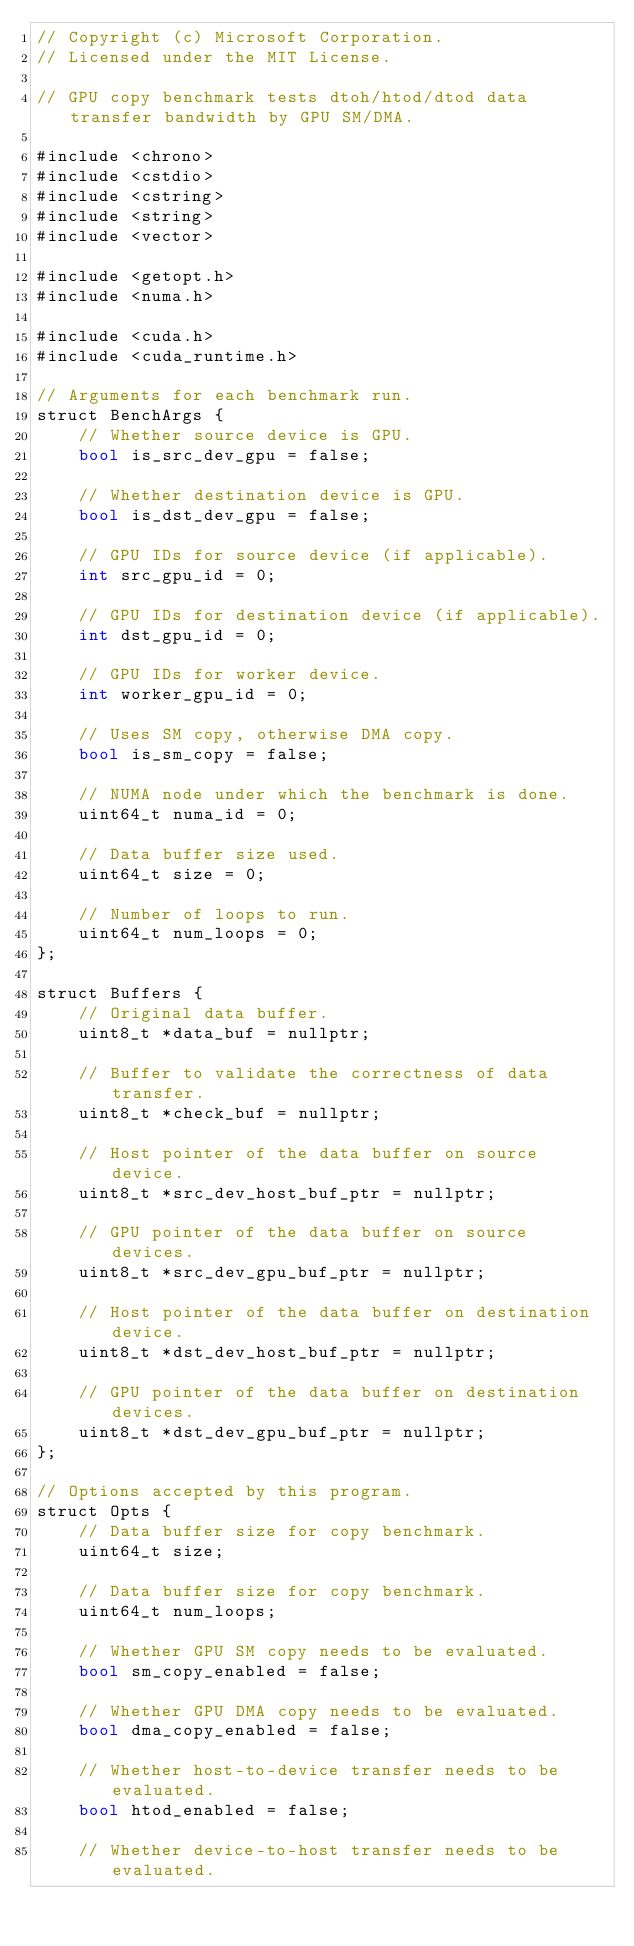Convert code to text. <code><loc_0><loc_0><loc_500><loc_500><_Cuda_>// Copyright (c) Microsoft Corporation.
// Licensed under the MIT License.

// GPU copy benchmark tests dtoh/htod/dtod data transfer bandwidth by GPU SM/DMA.

#include <chrono>
#include <cstdio>
#include <cstring>
#include <string>
#include <vector>

#include <getopt.h>
#include <numa.h>

#include <cuda.h>
#include <cuda_runtime.h>

// Arguments for each benchmark run.
struct BenchArgs {
    // Whether source device is GPU.
    bool is_src_dev_gpu = false;

    // Whether destination device is GPU.
    bool is_dst_dev_gpu = false;

    // GPU IDs for source device (if applicable).
    int src_gpu_id = 0;

    // GPU IDs for destination device (if applicable).
    int dst_gpu_id = 0;

    // GPU IDs for worker device.
    int worker_gpu_id = 0;

    // Uses SM copy, otherwise DMA copy.
    bool is_sm_copy = false;

    // NUMA node under which the benchmark is done.
    uint64_t numa_id = 0;

    // Data buffer size used.
    uint64_t size = 0;

    // Number of loops to run.
    uint64_t num_loops = 0;
};

struct Buffers {
    // Original data buffer.
    uint8_t *data_buf = nullptr;

    // Buffer to validate the correctness of data transfer.
    uint8_t *check_buf = nullptr;

    // Host pointer of the data buffer on source device.
    uint8_t *src_dev_host_buf_ptr = nullptr;

    // GPU pointer of the data buffer on source devices.
    uint8_t *src_dev_gpu_buf_ptr = nullptr;

    // Host pointer of the data buffer on destination device.
    uint8_t *dst_dev_host_buf_ptr = nullptr;

    // GPU pointer of the data buffer on destination devices.
    uint8_t *dst_dev_gpu_buf_ptr = nullptr;
};

// Options accepted by this program.
struct Opts {
    // Data buffer size for copy benchmark.
    uint64_t size;

    // Data buffer size for copy benchmark.
    uint64_t num_loops;

    // Whether GPU SM copy needs to be evaluated.
    bool sm_copy_enabled = false;

    // Whether GPU DMA copy needs to be evaluated.
    bool dma_copy_enabled = false;

    // Whether host-to-device transfer needs to be evaluated.
    bool htod_enabled = false;

    // Whether device-to-host transfer needs to be evaluated.</code> 